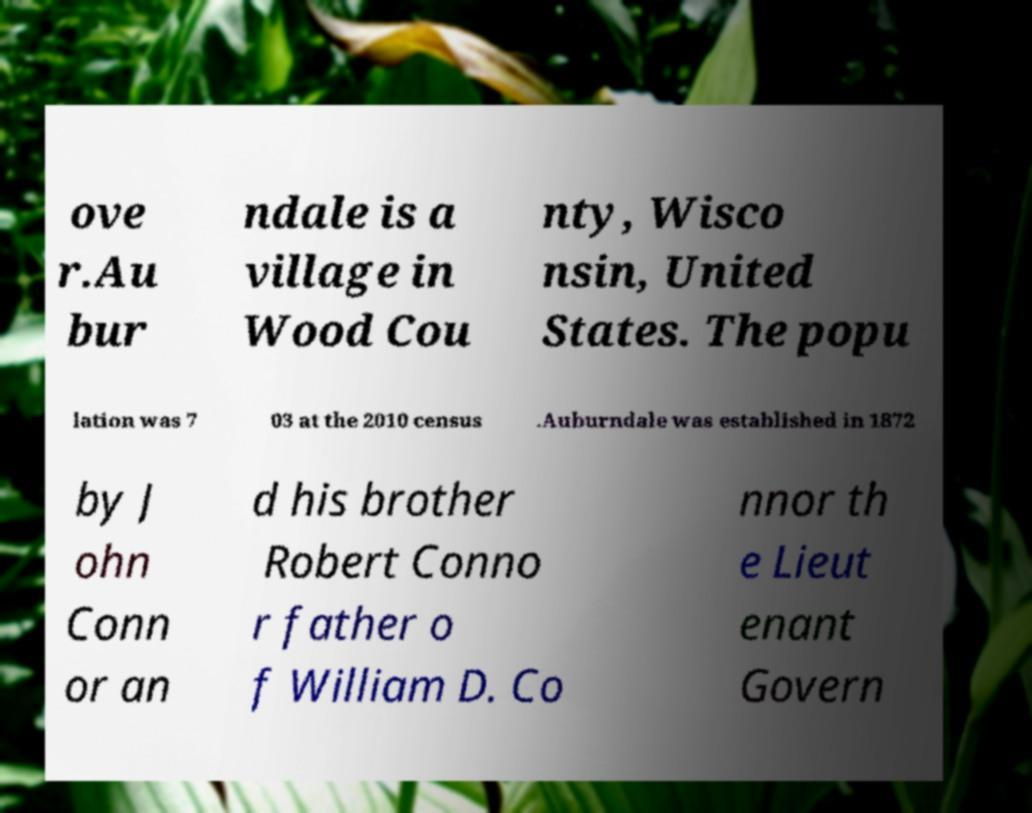Can you read and provide the text displayed in the image?This photo seems to have some interesting text. Can you extract and type it out for me? ove r.Au bur ndale is a village in Wood Cou nty, Wisco nsin, United States. The popu lation was 7 03 at the 2010 census .Auburndale was established in 1872 by J ohn Conn or an d his brother Robert Conno r father o f William D. Co nnor th e Lieut enant Govern 